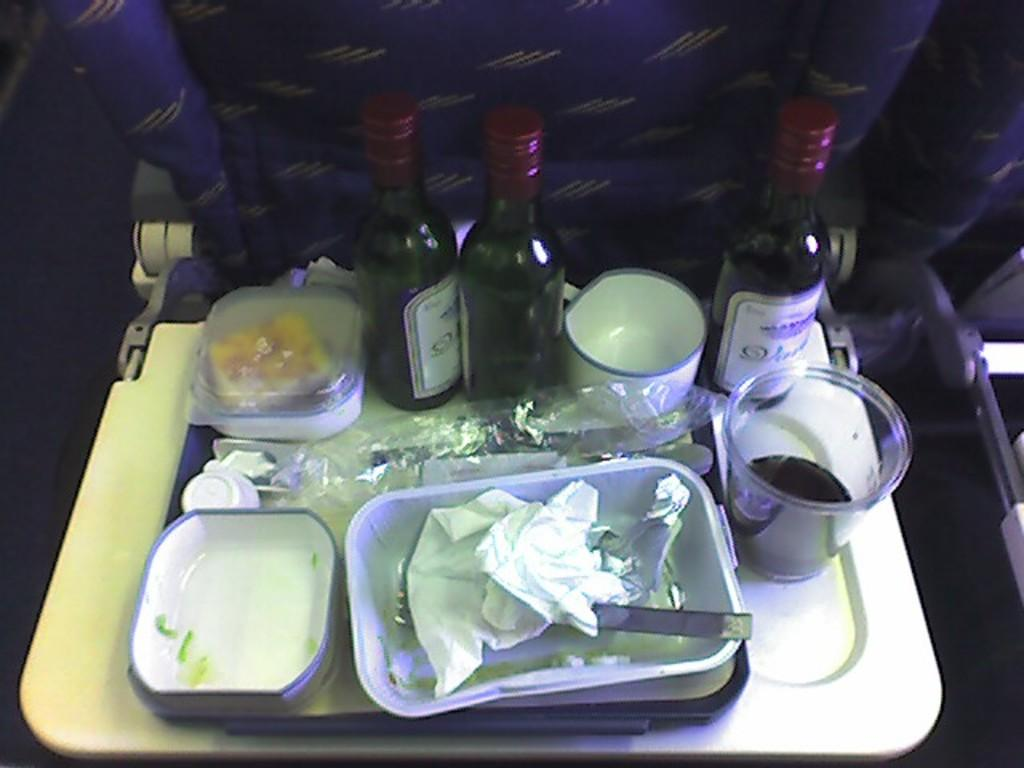Where was the image taken? The image was taken inside a plane. What can be seen in the image besides the plane's interior? There is a seat, boxes, bottles, cups, glasses, and spoons in the image. How are the items arranged in the image? The items are placed on a board attached to the seat. What type of mine can be seen in the image? There is no mine present in the image; it was taken inside a plane. How does the nerve affect the items in the image? There is no mention of a nerve in the image, and it does not have any effect on the items. 